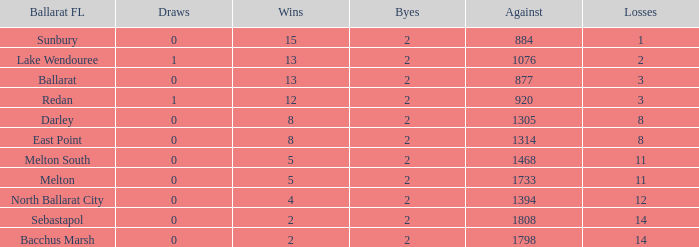How many Against has Byes smaller than 2? None. 